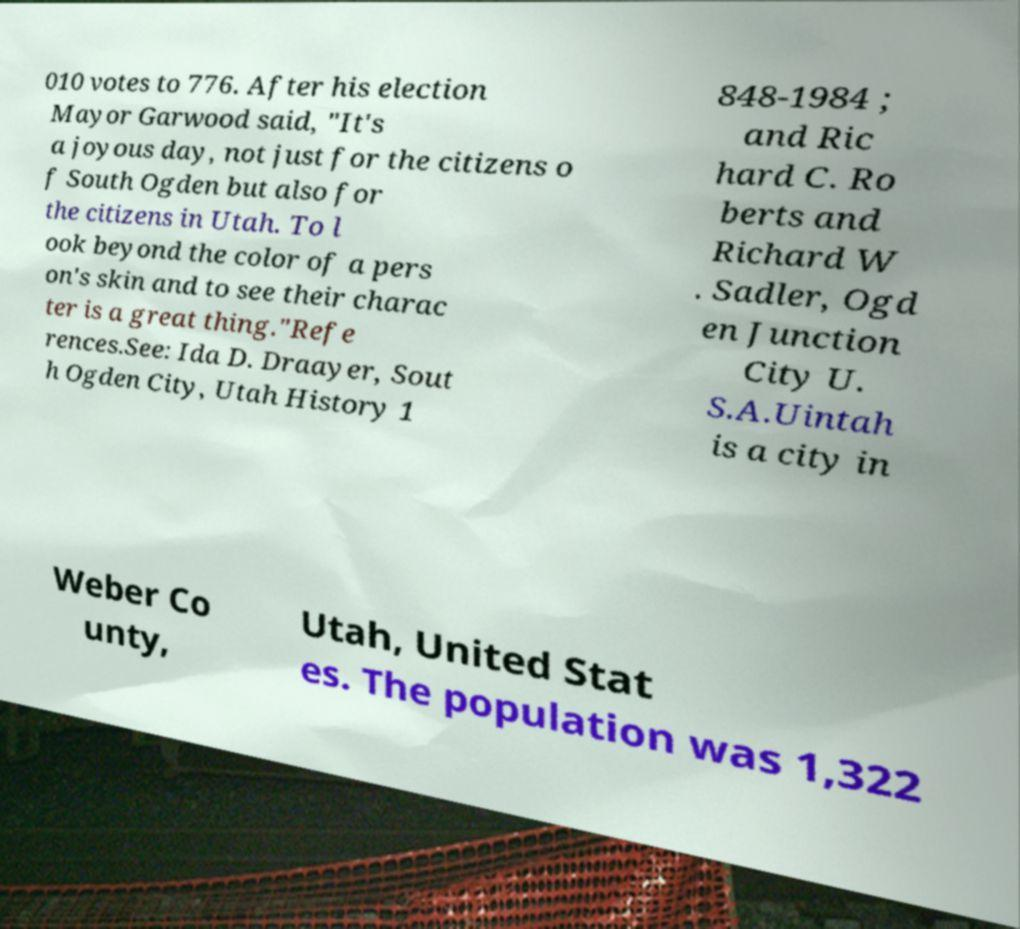What messages or text are displayed in this image? I need them in a readable, typed format. 010 votes to 776. After his election Mayor Garwood said, "It's a joyous day, not just for the citizens o f South Ogden but also for the citizens in Utah. To l ook beyond the color of a pers on's skin and to see their charac ter is a great thing."Refe rences.See: Ida D. Draayer, Sout h Ogden City, Utah History 1 848-1984 ; and Ric hard C. Ro berts and Richard W . Sadler, Ogd en Junction City U. S.A.Uintah is a city in Weber Co unty, Utah, United Stat es. The population was 1,322 